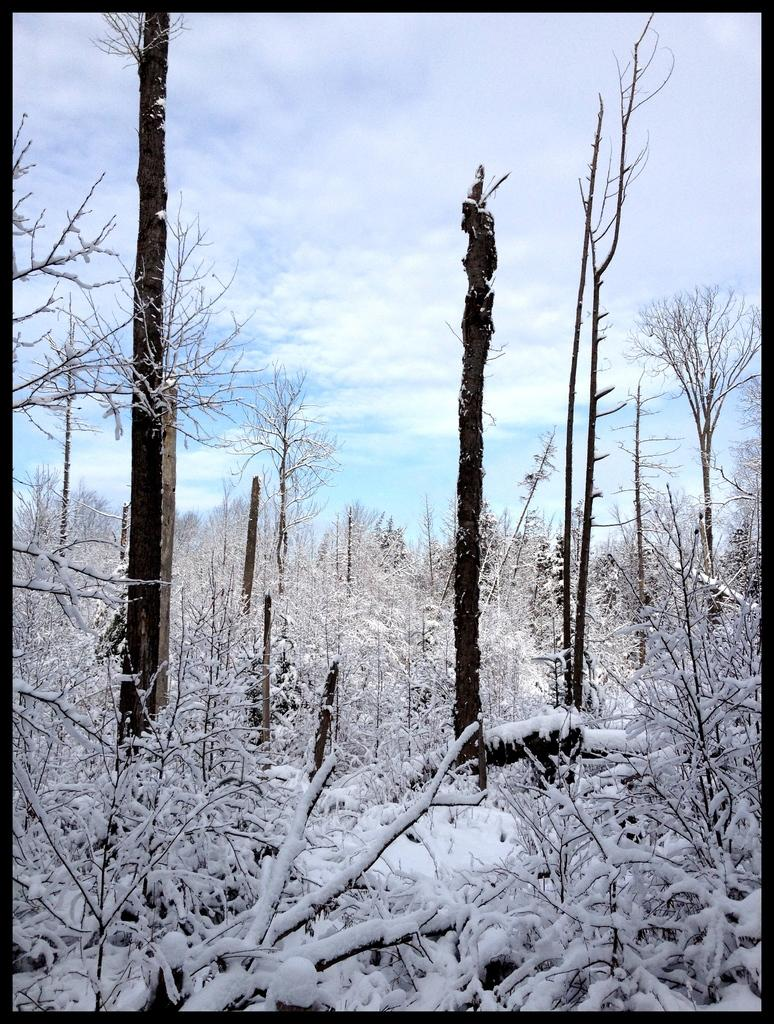What type of vegetation can be seen in the image? There are trees in the image. What is covering the trees in the image? The trees are covered with snow. What is visible in the background of the image? The sky is visible in the image. What can be observed in the sky? Clouds are present in the sky. What is the impulse of the unit in the image? There is no unit present in the image, so it is not possible to determine its impulse. 